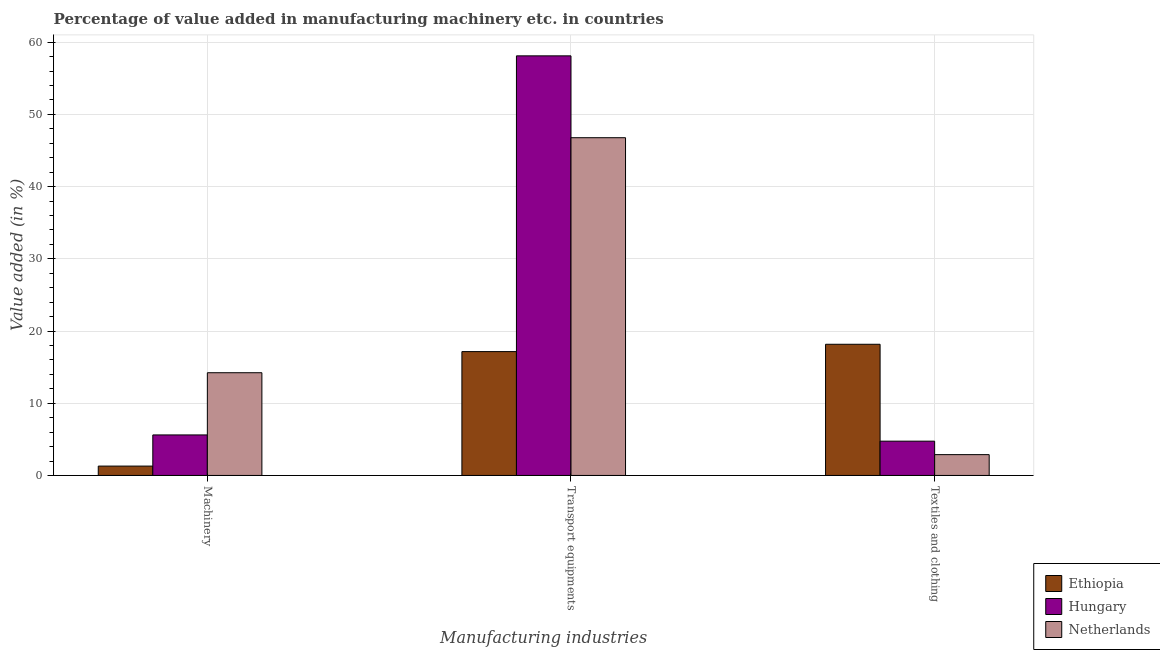Are the number of bars per tick equal to the number of legend labels?
Make the answer very short. Yes. Are the number of bars on each tick of the X-axis equal?
Ensure brevity in your answer.  Yes. How many bars are there on the 3rd tick from the right?
Your response must be concise. 3. What is the label of the 2nd group of bars from the left?
Keep it short and to the point. Transport equipments. What is the value added in manufacturing machinery in Netherlands?
Keep it short and to the point. 14.23. Across all countries, what is the maximum value added in manufacturing transport equipments?
Make the answer very short. 58.11. Across all countries, what is the minimum value added in manufacturing textile and clothing?
Offer a very short reply. 2.88. In which country was the value added in manufacturing transport equipments maximum?
Ensure brevity in your answer.  Hungary. In which country was the value added in manufacturing machinery minimum?
Keep it short and to the point. Ethiopia. What is the total value added in manufacturing transport equipments in the graph?
Offer a very short reply. 122.04. What is the difference between the value added in manufacturing machinery in Hungary and that in Ethiopia?
Keep it short and to the point. 4.32. What is the difference between the value added in manufacturing machinery in Netherlands and the value added in manufacturing transport equipments in Ethiopia?
Ensure brevity in your answer.  -2.93. What is the average value added in manufacturing machinery per country?
Your answer should be compact. 7.04. What is the difference between the value added in manufacturing textile and clothing and value added in manufacturing transport equipments in Hungary?
Your response must be concise. -53.36. What is the ratio of the value added in manufacturing machinery in Ethiopia to that in Hungary?
Provide a succinct answer. 0.23. Is the value added in manufacturing textile and clothing in Ethiopia less than that in Hungary?
Your response must be concise. No. What is the difference between the highest and the second highest value added in manufacturing transport equipments?
Your response must be concise. 11.34. What is the difference between the highest and the lowest value added in manufacturing machinery?
Make the answer very short. 12.93. In how many countries, is the value added in manufacturing machinery greater than the average value added in manufacturing machinery taken over all countries?
Offer a very short reply. 1. Is the sum of the value added in manufacturing textile and clothing in Ethiopia and Hungary greater than the maximum value added in manufacturing transport equipments across all countries?
Make the answer very short. No. What does the 1st bar from the left in Machinery represents?
Give a very brief answer. Ethiopia. What does the 2nd bar from the right in Machinery represents?
Make the answer very short. Hungary. Is it the case that in every country, the sum of the value added in manufacturing machinery and value added in manufacturing transport equipments is greater than the value added in manufacturing textile and clothing?
Your response must be concise. Yes. Are all the bars in the graph horizontal?
Give a very brief answer. No. How many countries are there in the graph?
Ensure brevity in your answer.  3. What is the difference between two consecutive major ticks on the Y-axis?
Give a very brief answer. 10. Does the graph contain grids?
Your answer should be compact. Yes. Where does the legend appear in the graph?
Give a very brief answer. Bottom right. What is the title of the graph?
Give a very brief answer. Percentage of value added in manufacturing machinery etc. in countries. What is the label or title of the X-axis?
Offer a terse response. Manufacturing industries. What is the label or title of the Y-axis?
Offer a terse response. Value added (in %). What is the Value added (in %) in Ethiopia in Machinery?
Your answer should be compact. 1.3. What is the Value added (in %) of Hungary in Machinery?
Your answer should be compact. 5.61. What is the Value added (in %) of Netherlands in Machinery?
Keep it short and to the point. 14.23. What is the Value added (in %) in Ethiopia in Transport equipments?
Your answer should be very brief. 17.15. What is the Value added (in %) in Hungary in Transport equipments?
Offer a terse response. 58.11. What is the Value added (in %) of Netherlands in Transport equipments?
Provide a succinct answer. 46.77. What is the Value added (in %) in Ethiopia in Textiles and clothing?
Ensure brevity in your answer.  18.17. What is the Value added (in %) in Hungary in Textiles and clothing?
Your response must be concise. 4.75. What is the Value added (in %) in Netherlands in Textiles and clothing?
Provide a short and direct response. 2.88. Across all Manufacturing industries, what is the maximum Value added (in %) in Ethiopia?
Your answer should be compact. 18.17. Across all Manufacturing industries, what is the maximum Value added (in %) in Hungary?
Provide a succinct answer. 58.11. Across all Manufacturing industries, what is the maximum Value added (in %) of Netherlands?
Provide a succinct answer. 46.77. Across all Manufacturing industries, what is the minimum Value added (in %) in Ethiopia?
Offer a very short reply. 1.3. Across all Manufacturing industries, what is the minimum Value added (in %) in Hungary?
Give a very brief answer. 4.75. Across all Manufacturing industries, what is the minimum Value added (in %) of Netherlands?
Your answer should be compact. 2.88. What is the total Value added (in %) of Ethiopia in the graph?
Make the answer very short. 36.61. What is the total Value added (in %) in Hungary in the graph?
Offer a terse response. 68.47. What is the total Value added (in %) of Netherlands in the graph?
Keep it short and to the point. 63.88. What is the difference between the Value added (in %) of Ethiopia in Machinery and that in Transport equipments?
Your response must be concise. -15.86. What is the difference between the Value added (in %) in Hungary in Machinery and that in Transport equipments?
Your response must be concise. -52.5. What is the difference between the Value added (in %) of Netherlands in Machinery and that in Transport equipments?
Offer a very short reply. -32.55. What is the difference between the Value added (in %) in Ethiopia in Machinery and that in Textiles and clothing?
Provide a short and direct response. -16.87. What is the difference between the Value added (in %) of Hungary in Machinery and that in Textiles and clothing?
Offer a terse response. 0.86. What is the difference between the Value added (in %) of Netherlands in Machinery and that in Textiles and clothing?
Keep it short and to the point. 11.34. What is the difference between the Value added (in %) in Ethiopia in Transport equipments and that in Textiles and clothing?
Your answer should be compact. -1.01. What is the difference between the Value added (in %) of Hungary in Transport equipments and that in Textiles and clothing?
Give a very brief answer. 53.36. What is the difference between the Value added (in %) in Netherlands in Transport equipments and that in Textiles and clothing?
Offer a very short reply. 43.89. What is the difference between the Value added (in %) in Ethiopia in Machinery and the Value added (in %) in Hungary in Transport equipments?
Ensure brevity in your answer.  -56.82. What is the difference between the Value added (in %) in Ethiopia in Machinery and the Value added (in %) in Netherlands in Transport equipments?
Provide a short and direct response. -45.48. What is the difference between the Value added (in %) in Hungary in Machinery and the Value added (in %) in Netherlands in Transport equipments?
Your answer should be very brief. -41.16. What is the difference between the Value added (in %) in Ethiopia in Machinery and the Value added (in %) in Hungary in Textiles and clothing?
Make the answer very short. -3.45. What is the difference between the Value added (in %) in Ethiopia in Machinery and the Value added (in %) in Netherlands in Textiles and clothing?
Ensure brevity in your answer.  -1.59. What is the difference between the Value added (in %) of Hungary in Machinery and the Value added (in %) of Netherlands in Textiles and clothing?
Your answer should be very brief. 2.73. What is the difference between the Value added (in %) of Ethiopia in Transport equipments and the Value added (in %) of Hungary in Textiles and clothing?
Ensure brevity in your answer.  12.4. What is the difference between the Value added (in %) of Ethiopia in Transport equipments and the Value added (in %) of Netherlands in Textiles and clothing?
Offer a very short reply. 14.27. What is the difference between the Value added (in %) in Hungary in Transport equipments and the Value added (in %) in Netherlands in Textiles and clothing?
Your answer should be very brief. 55.23. What is the average Value added (in %) in Ethiopia per Manufacturing industries?
Provide a succinct answer. 12.2. What is the average Value added (in %) in Hungary per Manufacturing industries?
Your answer should be compact. 22.82. What is the average Value added (in %) of Netherlands per Manufacturing industries?
Your answer should be very brief. 21.29. What is the difference between the Value added (in %) of Ethiopia and Value added (in %) of Hungary in Machinery?
Provide a succinct answer. -4.32. What is the difference between the Value added (in %) in Ethiopia and Value added (in %) in Netherlands in Machinery?
Your answer should be compact. -12.93. What is the difference between the Value added (in %) in Hungary and Value added (in %) in Netherlands in Machinery?
Keep it short and to the point. -8.61. What is the difference between the Value added (in %) of Ethiopia and Value added (in %) of Hungary in Transport equipments?
Make the answer very short. -40.96. What is the difference between the Value added (in %) of Ethiopia and Value added (in %) of Netherlands in Transport equipments?
Give a very brief answer. -29.62. What is the difference between the Value added (in %) in Hungary and Value added (in %) in Netherlands in Transport equipments?
Keep it short and to the point. 11.34. What is the difference between the Value added (in %) of Ethiopia and Value added (in %) of Hungary in Textiles and clothing?
Your answer should be compact. 13.42. What is the difference between the Value added (in %) of Ethiopia and Value added (in %) of Netherlands in Textiles and clothing?
Offer a very short reply. 15.28. What is the difference between the Value added (in %) in Hungary and Value added (in %) in Netherlands in Textiles and clothing?
Provide a short and direct response. 1.86. What is the ratio of the Value added (in %) of Ethiopia in Machinery to that in Transport equipments?
Your response must be concise. 0.08. What is the ratio of the Value added (in %) in Hungary in Machinery to that in Transport equipments?
Make the answer very short. 0.1. What is the ratio of the Value added (in %) in Netherlands in Machinery to that in Transport equipments?
Your answer should be very brief. 0.3. What is the ratio of the Value added (in %) in Ethiopia in Machinery to that in Textiles and clothing?
Provide a short and direct response. 0.07. What is the ratio of the Value added (in %) of Hungary in Machinery to that in Textiles and clothing?
Offer a terse response. 1.18. What is the ratio of the Value added (in %) of Netherlands in Machinery to that in Textiles and clothing?
Make the answer very short. 4.93. What is the ratio of the Value added (in %) in Ethiopia in Transport equipments to that in Textiles and clothing?
Make the answer very short. 0.94. What is the ratio of the Value added (in %) in Hungary in Transport equipments to that in Textiles and clothing?
Provide a short and direct response. 12.24. What is the ratio of the Value added (in %) in Netherlands in Transport equipments to that in Textiles and clothing?
Your response must be concise. 16.23. What is the difference between the highest and the second highest Value added (in %) of Ethiopia?
Offer a terse response. 1.01. What is the difference between the highest and the second highest Value added (in %) of Hungary?
Provide a succinct answer. 52.5. What is the difference between the highest and the second highest Value added (in %) in Netherlands?
Make the answer very short. 32.55. What is the difference between the highest and the lowest Value added (in %) of Ethiopia?
Offer a terse response. 16.87. What is the difference between the highest and the lowest Value added (in %) in Hungary?
Give a very brief answer. 53.36. What is the difference between the highest and the lowest Value added (in %) in Netherlands?
Offer a terse response. 43.89. 